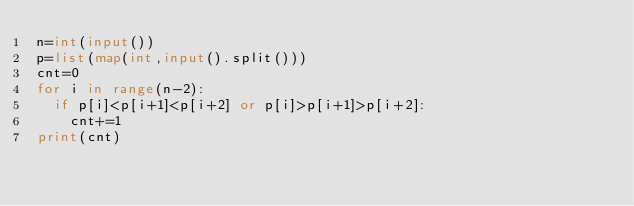Convert code to text. <code><loc_0><loc_0><loc_500><loc_500><_Python_>n=int(input())
p=list(map(int,input().split()))
cnt=0
for i in range(n-2):
  if p[i]<p[i+1]<p[i+2] or p[i]>p[i+1]>p[i+2]:
    cnt+=1
print(cnt)
    </code> 